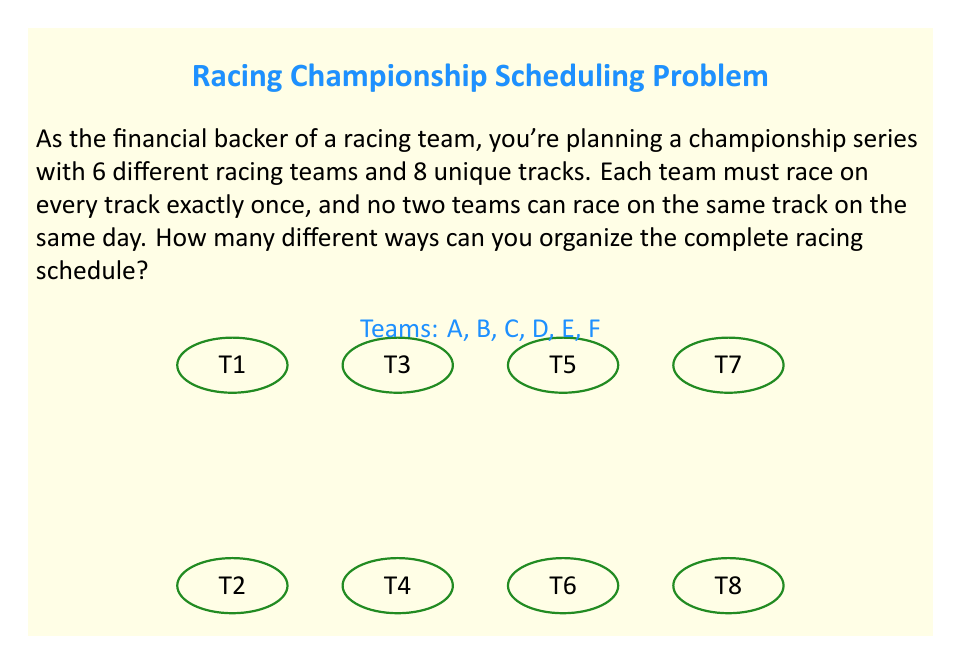Solve this math problem. Let's approach this step-by-step:

1) First, we need to understand what we're counting. We're essentially creating a schedule where each team races on each track once, with no overlaps.

2) This scenario can be modeled as a Latin rectangle. A Latin rectangle is an $r \times n$ array filled with $n$ symbols, where each symbol appears exactly once in each row and at most once in each column.

3) In our case:
   - We have 6 rows (one for each team)
   - We have 8 columns (one for each track)
   - We're filling the rectangle with 8 symbols (representing the order of races)

4) The number of ways to create such a Latin rectangle is given by the formula:

   $$N = n! \cdot (n-1)! \cdot (n-2)! \cdot ... \cdot (n-r+1)!$$

   Where $n$ is the number of columns (tracks) and $r$ is the number of rows (teams).

5) In our case, $n = 8$ and $r = 6$. So we need to calculate:

   $$N = 8! \cdot 7! \cdot 6! \cdot 5! \cdot 4! \cdot 3!$$

6) Let's compute this step by step:
   
   $8! = 40,320$
   $7! = 5,040$
   $6! = 720$
   $5! = 120$
   $4! = 24$
   $3! = 6$

7) Multiplying these together:

   $$N = 40,320 \cdot 5,040 \cdot 720 \cdot 120 \cdot 24 \cdot 6$$

8) This equals: 3,741,465,600,000,000

Thus, there are 3,741,465,600,000,000 different ways to organize the complete racing schedule.
Answer: $3.74 \times 10^{15}$ 